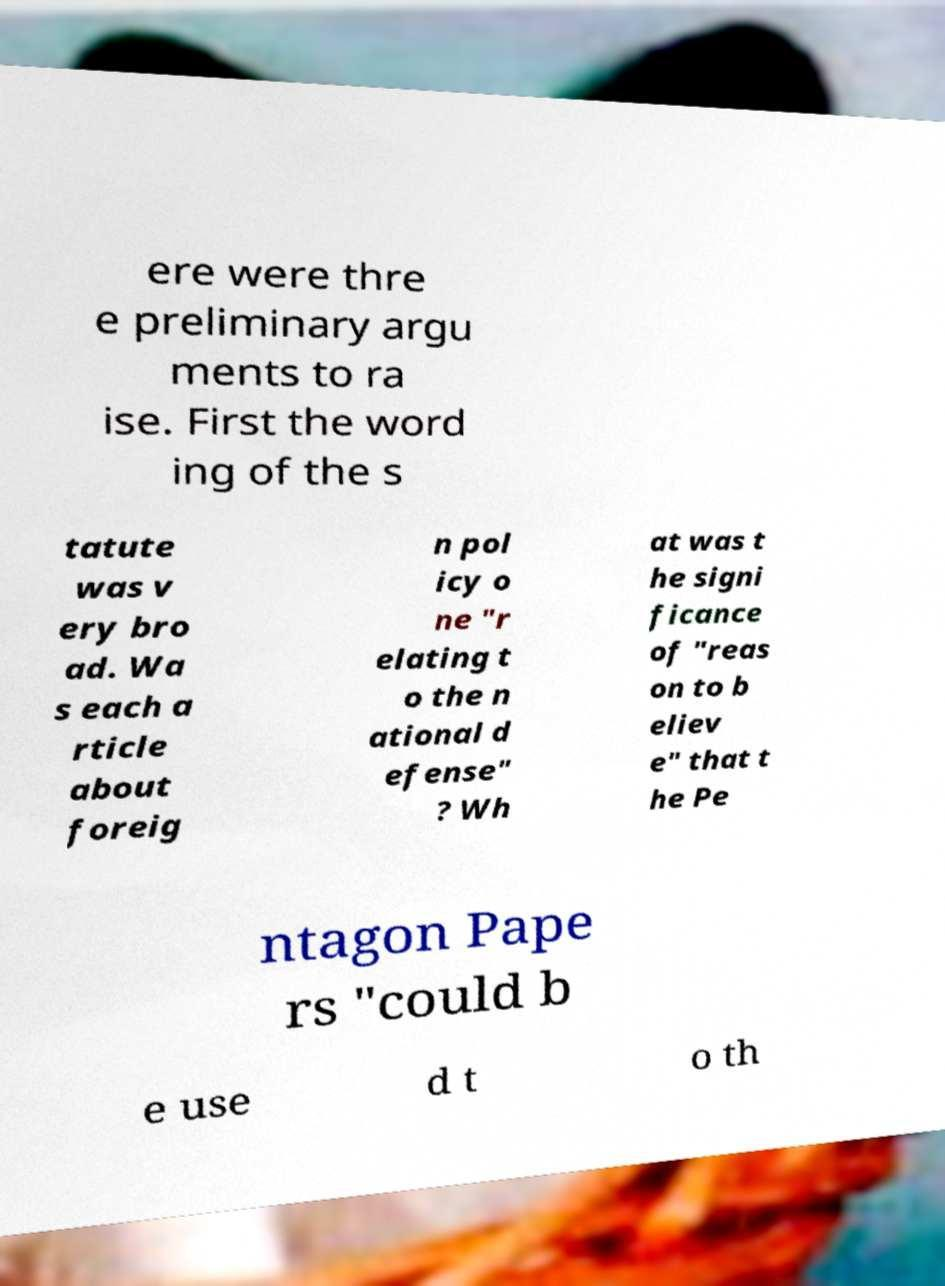Please read and relay the text visible in this image. What does it say? ere were thre e preliminary argu ments to ra ise. First the word ing of the s tatute was v ery bro ad. Wa s each a rticle about foreig n pol icy o ne "r elating t o the n ational d efense" ? Wh at was t he signi ficance of "reas on to b eliev e" that t he Pe ntagon Pape rs "could b e use d t o th 